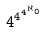<formula> <loc_0><loc_0><loc_500><loc_500>4 ^ { 4 ^ { 4 ^ { \aleph _ { 0 } } } }</formula> 